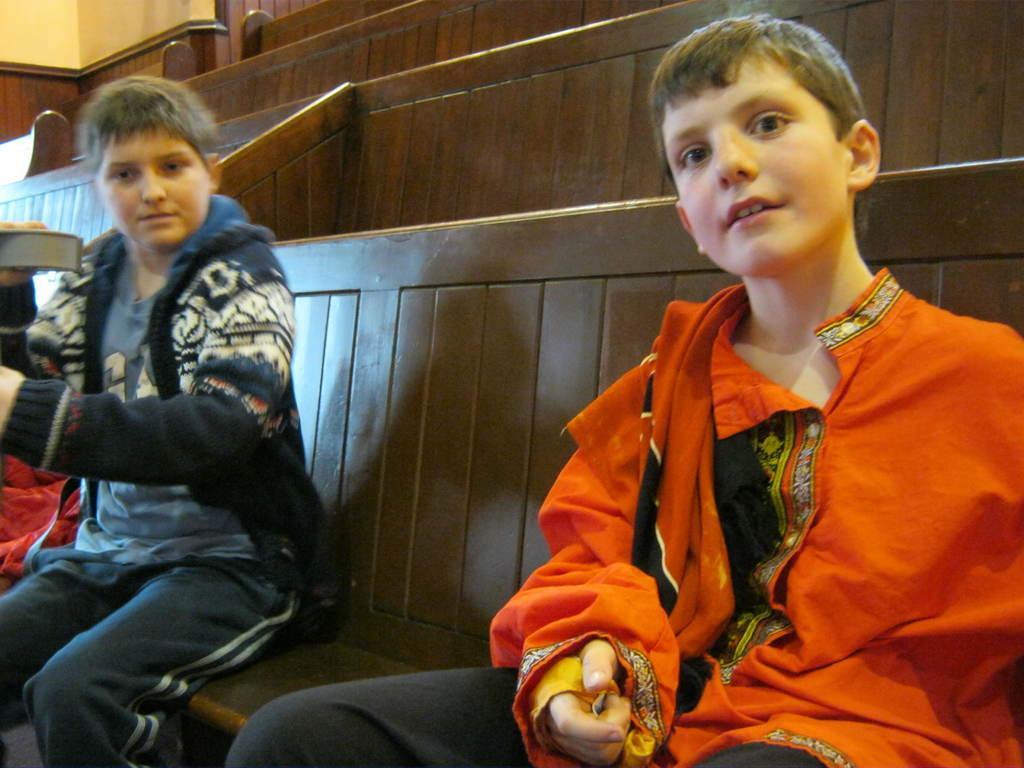How would you summarize this image in a sentence or two? In this image there are two boys sitting on a bench, one of them is holding an object. In the background there are few more benches. 